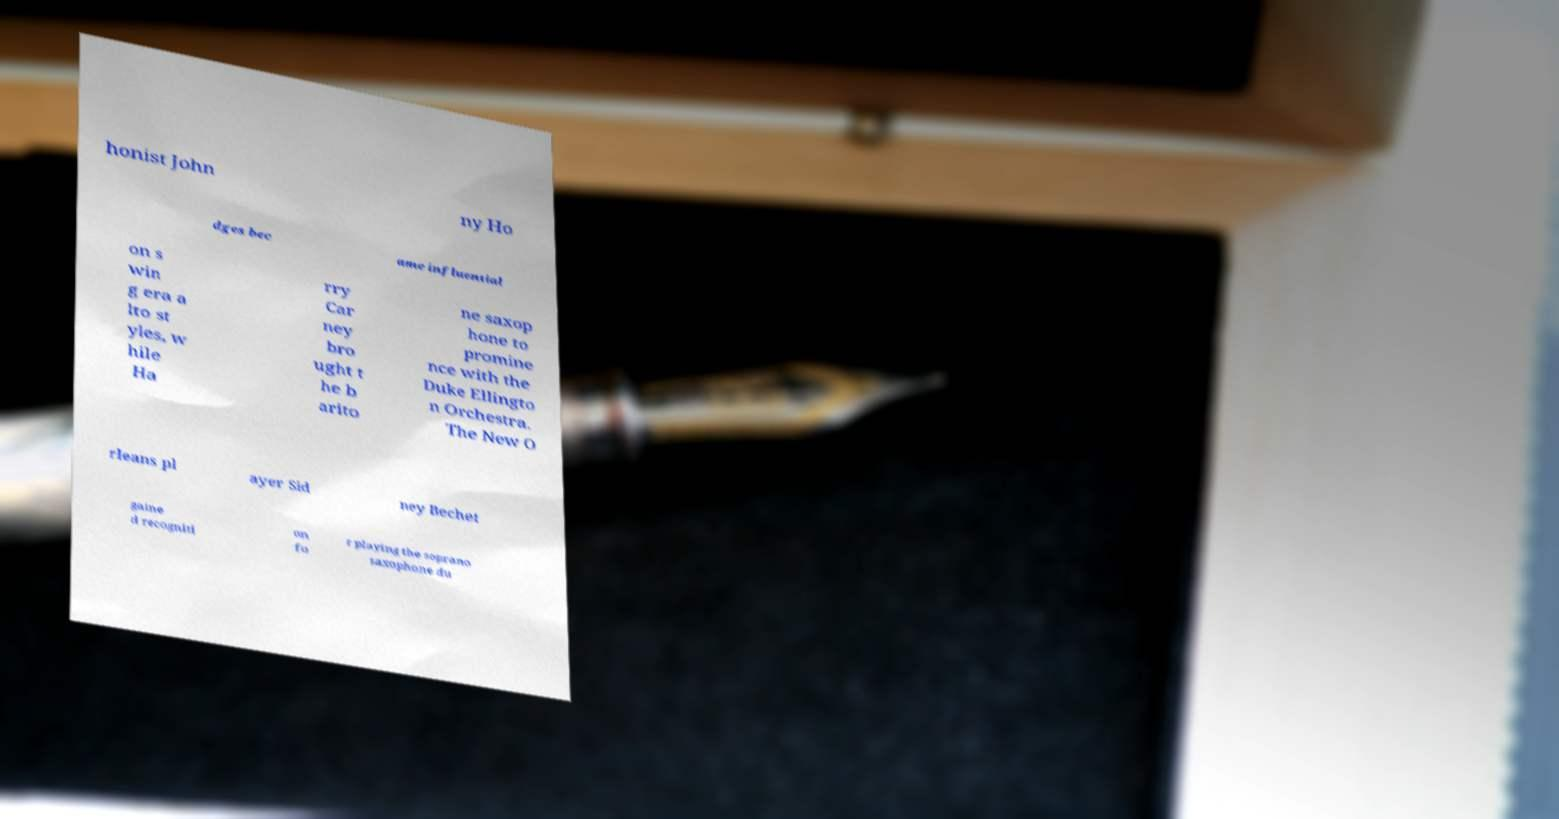Can you read and provide the text displayed in the image?This photo seems to have some interesting text. Can you extract and type it out for me? honist John ny Ho dges bec ame influential on s win g era a lto st yles, w hile Ha rry Car ney bro ught t he b arito ne saxop hone to promine nce with the Duke Ellingto n Orchestra. The New O rleans pl ayer Sid ney Bechet gaine d recogniti on fo r playing the soprano saxophone du 